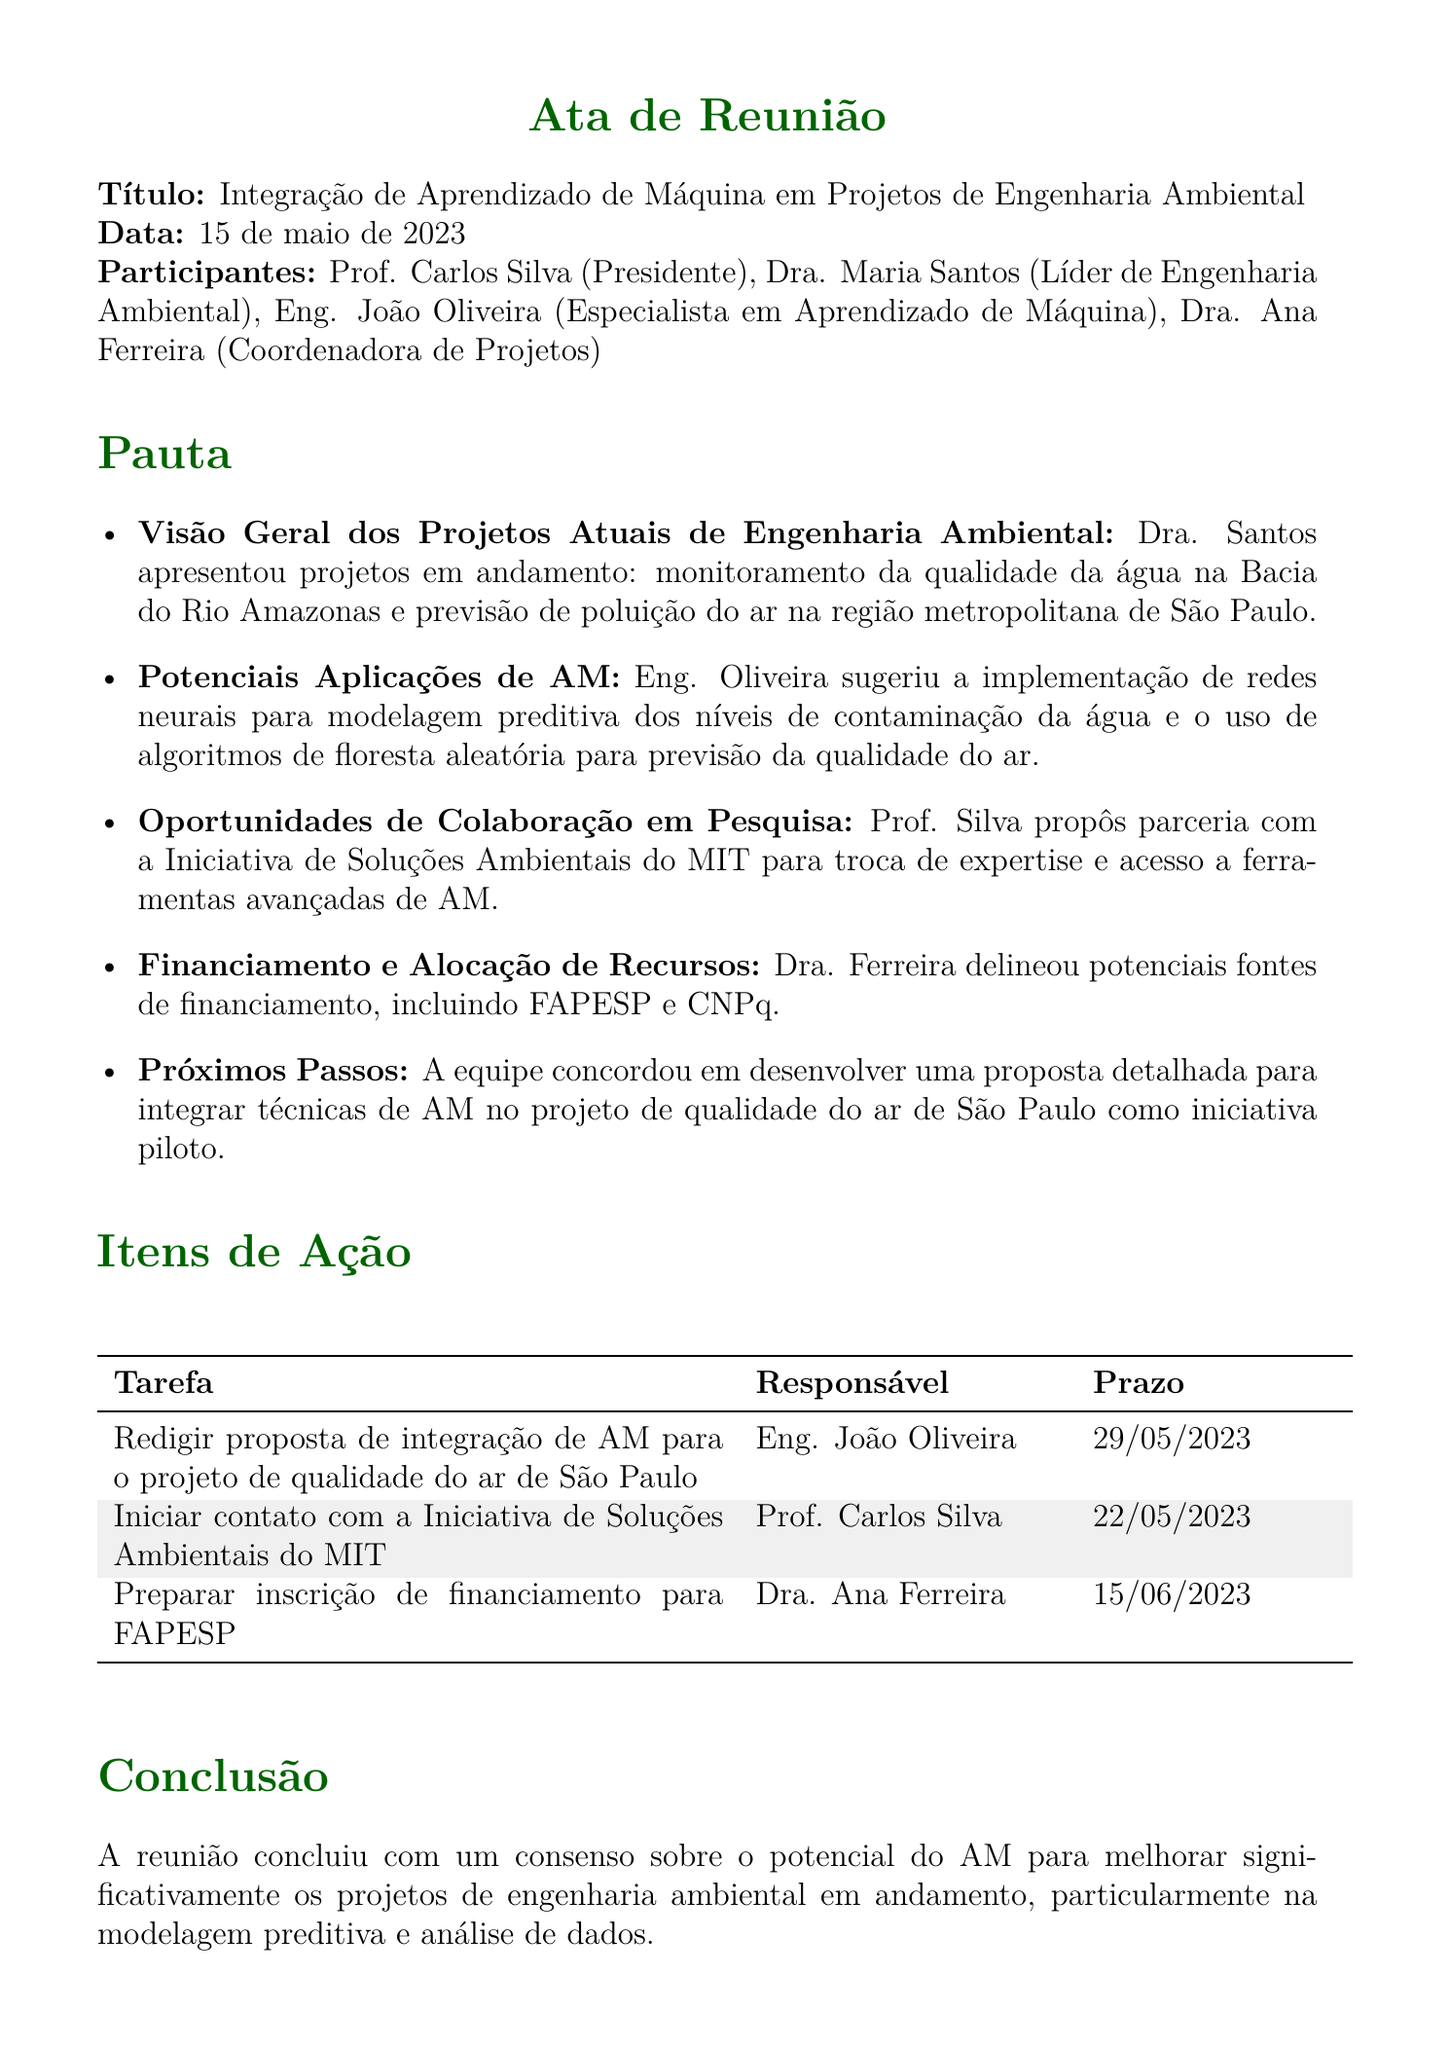Qual é o título da reunião? O título da reunião é um elemento central do documento de atas que indica o tema discutido.
Answer: Integração de Aprendizado de Máquina em Projetos de Engenharia Ambiental Quem apresentou a visão geral dos projetos atuais? A apresentação da visão geral dos projetos é feita por um dos participantes e é um detalhe importante.
Answer: Dra. Maria Santos Qual é a data da reunião? A data da reunião é essencial para o registro temporal dos eventos discutidos.
Answer: 15 de maio de 2023 Quais algoritmos foram sugeridos para previsão de poluição do ar? A menção de algoritmos específicos demonstra as aplicações práticas discutidas na reunião.
Answer: algoritmos de floresta aleatória Quem é o responsável pela proposta de integração de AM? Informações sobre responsabilidades ajudam a atribuir tarefas e acompanhamento de progresso.
Answer: Eng. João Oliveira Quando é o prazo para iniciar contato com o MIT? O prazo indica a urgência e a organização do projeto em questão.
Answer: 22/05/2023 Quais são as fontes de financiamento mencionadas? Entender as fontes de financiamento é crucial para o planejamento de recursos do projeto.
Answer: FAPESP e CNPq Qual o objetivo da proposta a ser desenvolvida? O objetivo da proposta define a aplicação prática das discussões da reunião.
Answer: integrar técnicas de AM no projeto de qualidade do ar de São Paulo Qual foi a conclusão da reunião? A conclusão resume a essência da discussão e o potencial identificado durante a reunião.
Answer: potencial do AM para melhorar significativamente os projetos de engenharia ambiental 